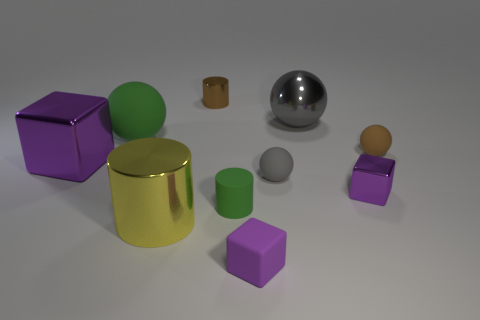There is a tiny object that is the same color as the big matte ball; what shape is it?
Give a very brief answer. Cylinder. There is a big sphere behind the large sphere left of the tiny brown shiny thing; is there a large sphere in front of it?
Your response must be concise. Yes. Is the size of the gray rubber thing the same as the brown ball?
Offer a terse response. Yes. Are there the same number of tiny objects that are in front of the yellow cylinder and metallic cylinders in front of the green cylinder?
Your answer should be compact. Yes. What shape is the gray object that is to the right of the small gray object?
Make the answer very short. Sphere. There is a green rubber thing that is the same size as the gray metal thing; what shape is it?
Keep it short and to the point. Sphere. What is the color of the shiny block that is to the right of the large thing that is to the right of the green object that is in front of the big rubber thing?
Your answer should be compact. Purple. Do the large rubber object and the tiny green matte object have the same shape?
Ensure brevity in your answer.  No. Is the number of purple metal objects that are behind the yellow shiny cylinder the same as the number of small cubes?
Your answer should be compact. Yes. How many other things are there of the same material as the tiny gray thing?
Make the answer very short. 4. 